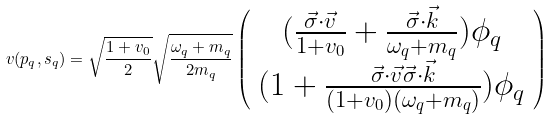<formula> <loc_0><loc_0><loc_500><loc_500>v ( p _ { q } , s _ { q } ) = \sqrt { \frac { 1 + v _ { 0 } } { 2 } } \sqrt { \frac { \omega _ { q } + m _ { q } } { 2 m _ { q } } } \left ( \begin{array} { c } ( \frac { \vec { \sigma } \cdot \vec { v } } { 1 + v _ { 0 } } + \frac { \vec { \sigma } \cdot \vec { k } } { \omega _ { q } + m _ { q } } ) \phi _ { q } \\ ( 1 + \frac { \vec { \sigma } \cdot \vec { v } \vec { \sigma } \cdot \vec { k } } { ( 1 + v _ { 0 } ) ( \omega _ { q } + m _ { q } ) } ) \phi _ { q } \end{array} \right )</formula> 